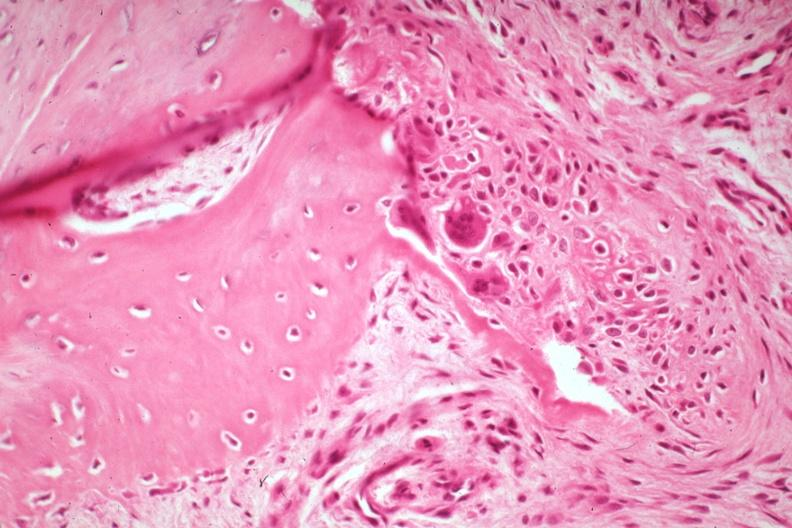what does this image show?
Answer the question using a single word or phrase. High excellent osteoid deposition with osteoclasts there is a fracture 